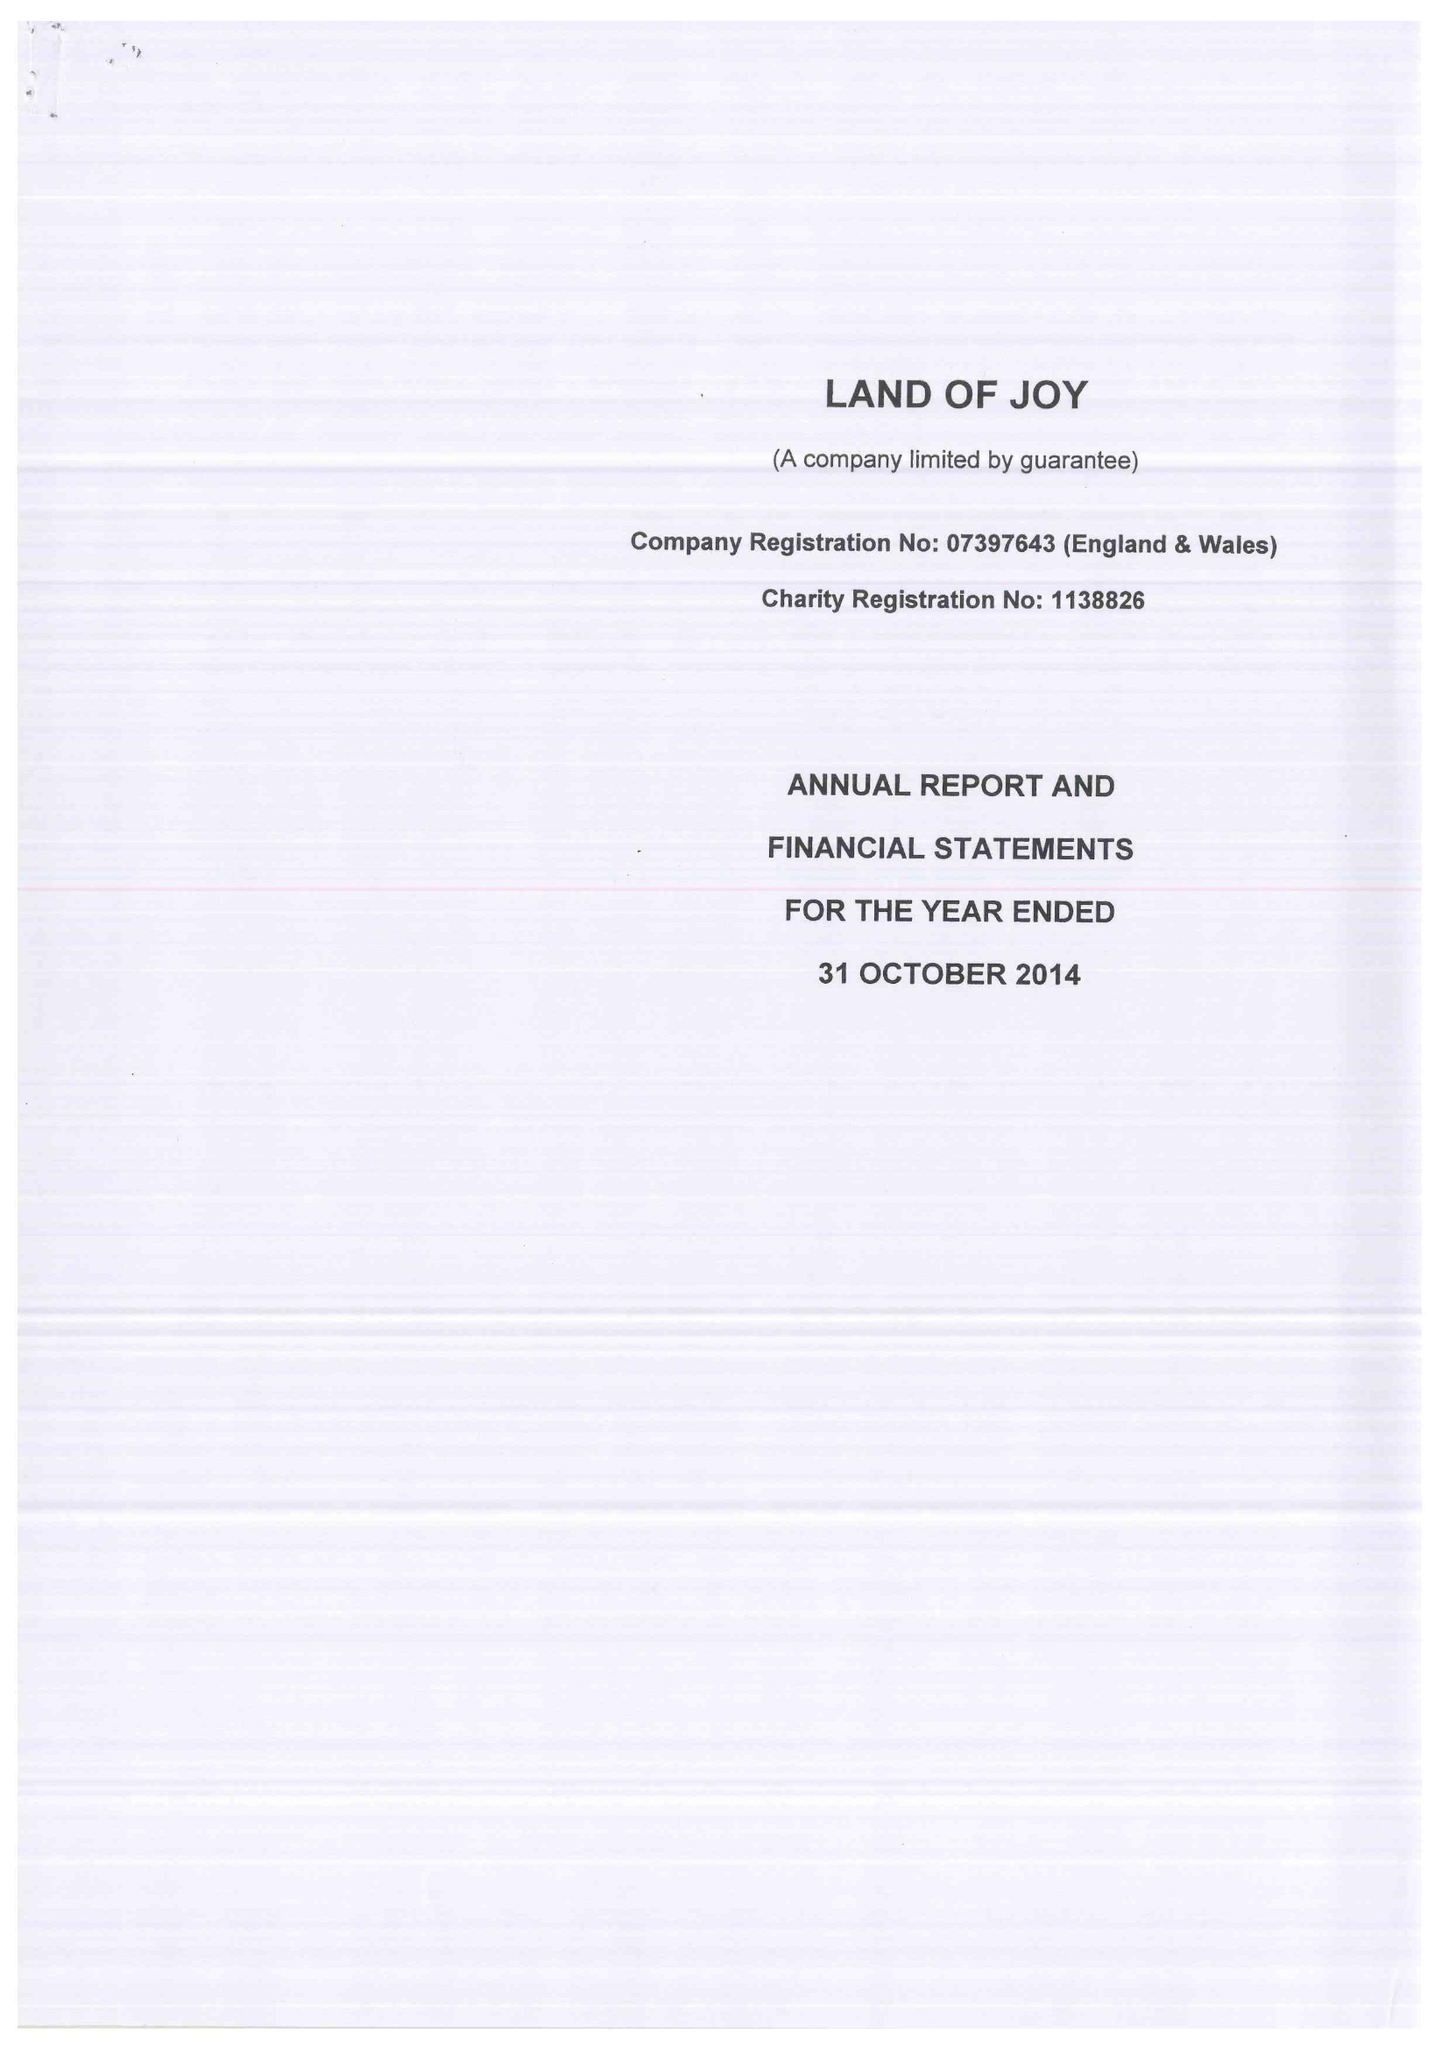What is the value for the charity_name?
Answer the question using a single word or phrase. Land Of Joy 